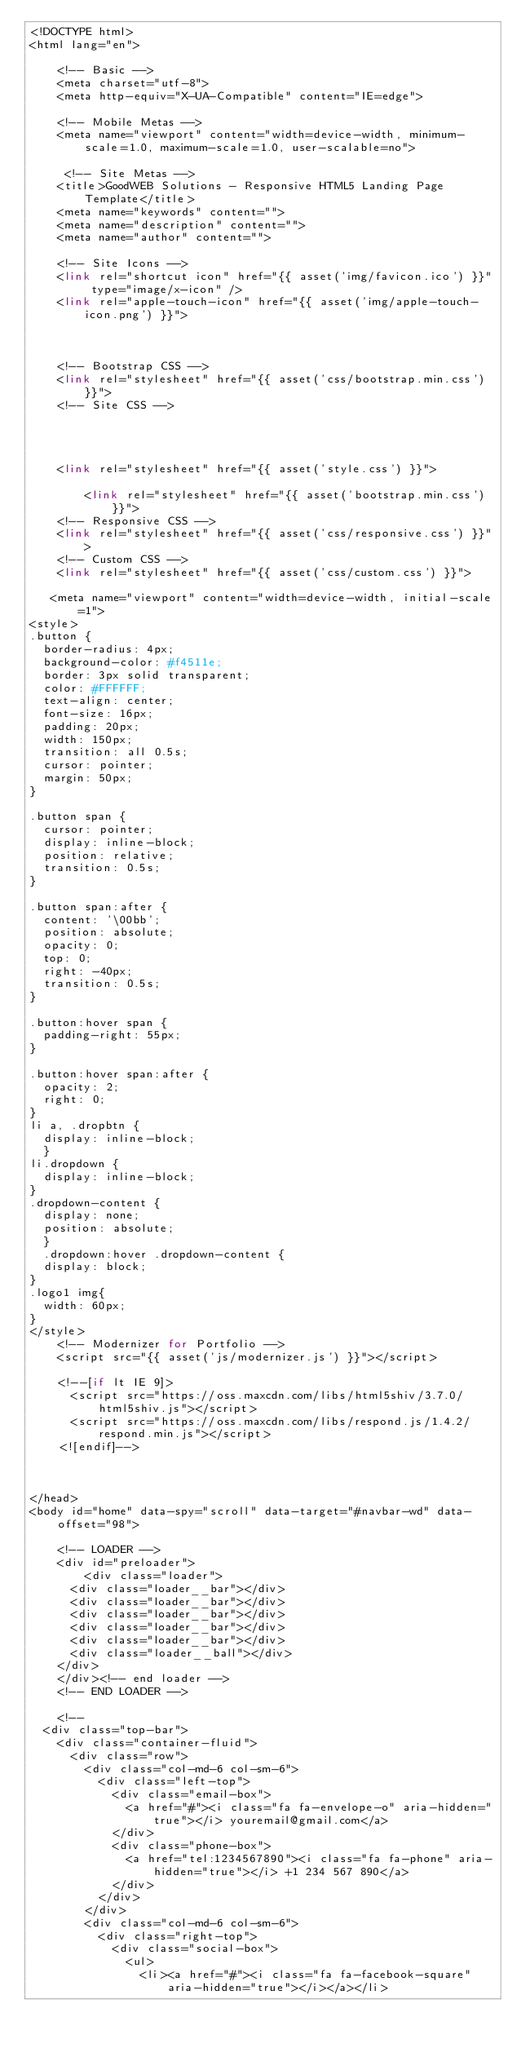<code> <loc_0><loc_0><loc_500><loc_500><_PHP_><!DOCTYPE html>
<html lang="en">

    <!-- Basic -->
    <meta charset="utf-8">
    <meta http-equiv="X-UA-Compatible" content="IE=edge">   
   
    <!-- Mobile Metas -->
    <meta name="viewport" content="width=device-width, minimum-scale=1.0, maximum-scale=1.0, user-scalable=no">
 
     <!-- Site Metas -->
    <title>GoodWEB Solutions - Responsive HTML5 Landing Page Template</title>  
    <meta name="keywords" content="">
    <meta name="description" content="">
    <meta name="author" content="">

    <!-- Site Icons -->
    <link rel="shortcut icon" href="{{ asset('img/favicon.ico') }}" type="image/x-icon" />
    <link rel="apple-touch-icon" href="{{ asset('img/apple-touch-icon.png') }}">



    <!-- Bootstrap CSS -->
    <link rel="stylesheet" href="{{ asset('css/bootstrap.min.css') }}">
    <!-- Site CSS -->




    <link rel="stylesheet" href="{{ asset('style.css') }}">

        <link rel="stylesheet" href="{{ asset('bootstrap.min.css') }}">
    <!-- Responsive CSS -->
    <link rel="stylesheet" href="{{ asset('css/responsive.css') }}">
    <!-- Custom CSS -->
    <link rel="stylesheet" href="{{ asset('css/custom.css') }}">

   <meta name="viewport" content="width=device-width, initial-scale=1">
<style>
.button {
  border-radius: 4px;
  background-color: #f4511e;
  border: 3px solid transparent;
  color: #FFFFFF;
  text-align: center;
  font-size: 16px;
  padding: 20px;
  width: 150px;
  transition: all 0.5s;
  cursor: pointer;
  margin: 50px;
}

.button span {
  cursor: pointer;
  display: inline-block;
  position: relative;
  transition: 0.5s;
}

.button span:after {
  content: '\00bb';
  position: absolute;
  opacity: 0;
  top: 0;
  right: -40px;
  transition: 0.5s;
}

.button:hover span {
  padding-right: 55px;
}

.button:hover span:after {
  opacity: 2;
  right: 0;
}
li a, .dropbtn {
  display: inline-block;
  }
li.dropdown {
  display: inline-block;
}
.dropdown-content {
  display: none; 
  position: absolute;
  }
  .dropdown:hover .dropdown-content {
  display: block;
}
.logo1 img{
  width: 60px;
}
</style>
    <!-- Modernizer for Portfolio -->
    <script src="{{ asset('js/modernizer.js') }}"></script>

    <!--[if lt IE 9]>
      <script src="https://oss.maxcdn.com/libs/html5shiv/3.7.0/html5shiv.js"></script>
      <script src="https://oss.maxcdn.com/libs/respond.js/1.4.2/respond.min.js"></script>
    <![endif]-->
    
    

</head>
<body id="home" data-spy="scroll" data-target="#navbar-wd" data-offset="98">

    <!-- LOADER -->
    <div id="preloader">
        <div class="loader">
      <div class="loader__bar"></div>
      <div class="loader__bar"></div>
      <div class="loader__bar"></div>
      <div class="loader__bar"></div>
      <div class="loader__bar"></div>
      <div class="loader__ball"></div>
    </div>
    </div><!-- end loader -->
    <!-- END LOADER -->
    
    <!--
  <div class="top-bar">
    <div class="container-fluid">
      <div class="row">
        <div class="col-md-6 col-sm-6">
          <div class="left-top">
            <div class="email-box">
              <a href="#"><i class="fa fa-envelope-o" aria-hidden="true"></i> youremail@gmail.com</a>
            </div>
            <div class="phone-box">
              <a href="tel:1234567890"><i class="fa fa-phone" aria-hidden="true"></i> +1 234 567 890</a>
            </div>
          </div>
        </div>
        <div class="col-md-6 col-sm-6">
          <div class="right-top">
            <div class="social-box">
              <ul>
                <li><a href="#"><i class="fa fa-facebook-square" aria-hidden="true"></i></a></li></code> 